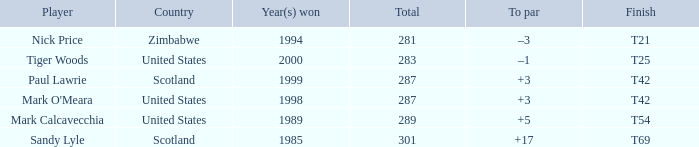What is the to par when the year(s) won is larger than 1999? –1. Can you parse all the data within this table? {'header': ['Player', 'Country', 'Year(s) won', 'Total', 'To par', 'Finish'], 'rows': [['Nick Price', 'Zimbabwe', '1994', '281', '–3', 'T21'], ['Tiger Woods', 'United States', '2000', '283', '–1', 'T25'], ['Paul Lawrie', 'Scotland', '1999', '287', '+3', 'T42'], ["Mark O'Meara", 'United States', '1998', '287', '+3', 'T42'], ['Mark Calcavecchia', 'United States', '1989', '289', '+5', 'T54'], ['Sandy Lyle', 'Scotland', '1985', '301', '+17', 'T69']]} 